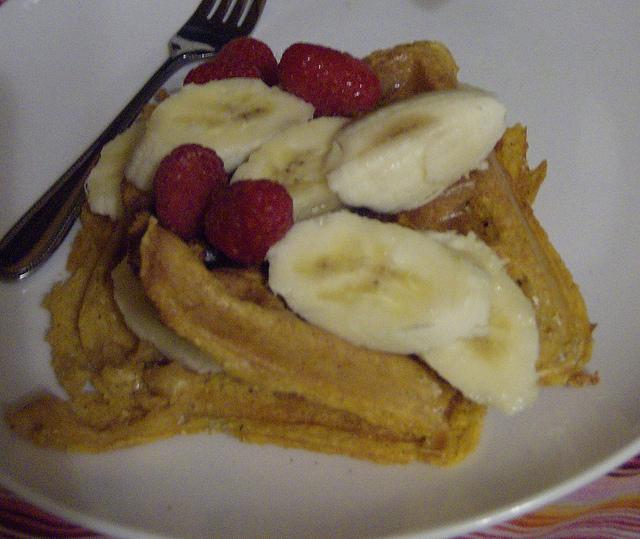How many cherries are on top?
Give a very brief answer. 0. 